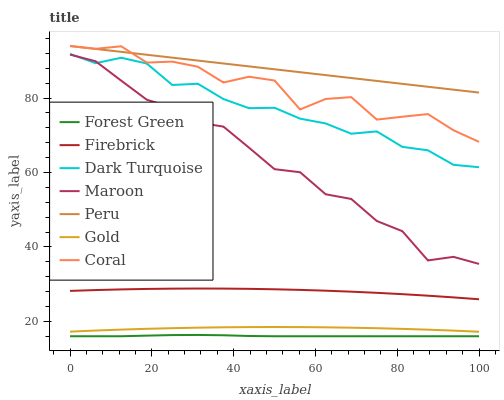Does Forest Green have the minimum area under the curve?
Answer yes or no. Yes. Does Peru have the maximum area under the curve?
Answer yes or no. Yes. Does Dark Turquoise have the minimum area under the curve?
Answer yes or no. No. Does Dark Turquoise have the maximum area under the curve?
Answer yes or no. No. Is Peru the smoothest?
Answer yes or no. Yes. Is Coral the roughest?
Answer yes or no. Yes. Is Dark Turquoise the smoothest?
Answer yes or no. No. Is Dark Turquoise the roughest?
Answer yes or no. No. Does Forest Green have the lowest value?
Answer yes or no. Yes. Does Dark Turquoise have the lowest value?
Answer yes or no. No. Does Coral have the highest value?
Answer yes or no. Yes. Does Dark Turquoise have the highest value?
Answer yes or no. No. Is Gold less than Maroon?
Answer yes or no. Yes. Is Peru greater than Dark Turquoise?
Answer yes or no. Yes. Does Maroon intersect Dark Turquoise?
Answer yes or no. Yes. Is Maroon less than Dark Turquoise?
Answer yes or no. No. Is Maroon greater than Dark Turquoise?
Answer yes or no. No. Does Gold intersect Maroon?
Answer yes or no. No. 